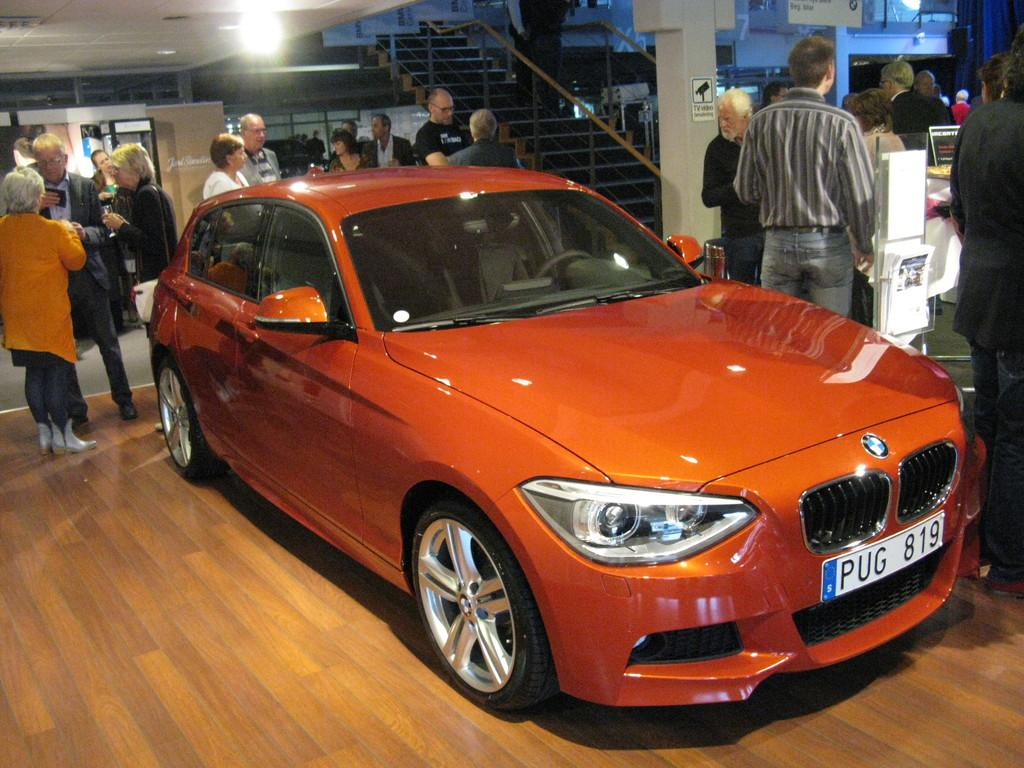What type of car is in the image? There is an orange color BMW car in the image. What are the people behind the car doing? The people standing and talking behind the car are engaged in conversation. Can you describe any architectural features in the image? Yes, there is a stair present in the image. What material is used for the floor in the image? The floor is furnished with wood. What type of trees can be seen in the image? There are no trees present in the image. What medical advice can be given by the doctor in the image? There is no doctor present in the image. 